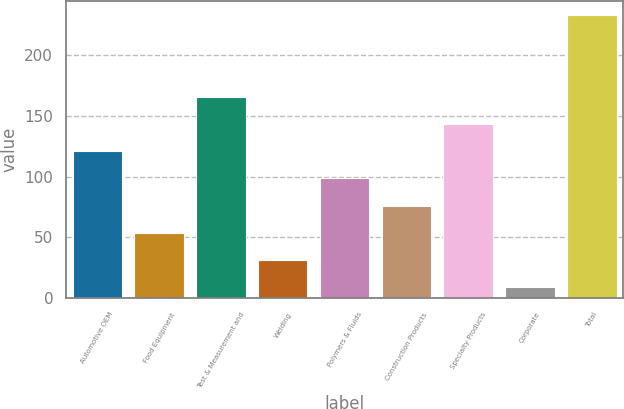Convert chart. <chart><loc_0><loc_0><loc_500><loc_500><bar_chart><fcel>Automotive OEM<fcel>Food Equipment<fcel>Test & Measurement and<fcel>Welding<fcel>Polymers & Fluids<fcel>Construction Products<fcel>Specialty Products<fcel>Corporate<fcel>Total<nl><fcel>121<fcel>53.8<fcel>165.8<fcel>31.4<fcel>98.6<fcel>76.2<fcel>143.4<fcel>9<fcel>233<nl></chart> 